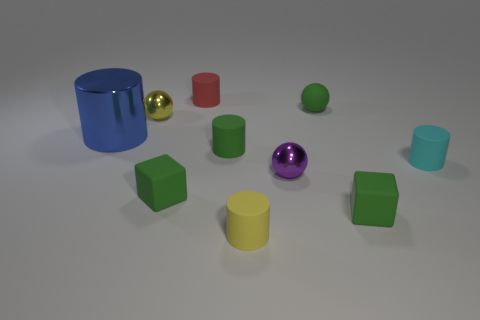What material is the green sphere that is the same size as the red matte thing?
Offer a terse response. Rubber. What size is the ball that is left of the red object?
Keep it short and to the point. Small. Does the cylinder that is behind the large thing have the same size as the shiny sphere left of the red thing?
Ensure brevity in your answer.  Yes. What number of tiny green objects are made of the same material as the yellow cylinder?
Your response must be concise. 4. The big metal thing is what color?
Your answer should be very brief. Blue. There is a blue cylinder; are there any tiny objects behind it?
Provide a succinct answer. Yes. How many other shiny cylinders have the same color as the big metallic cylinder?
Your answer should be compact. 0. There is a metal sphere that is to the left of the purple metal sphere right of the red cylinder; what is its size?
Offer a terse response. Small. The blue metal object is what shape?
Give a very brief answer. Cylinder. What material is the yellow object that is to the right of the tiny red rubber cylinder?
Provide a succinct answer. Rubber. 